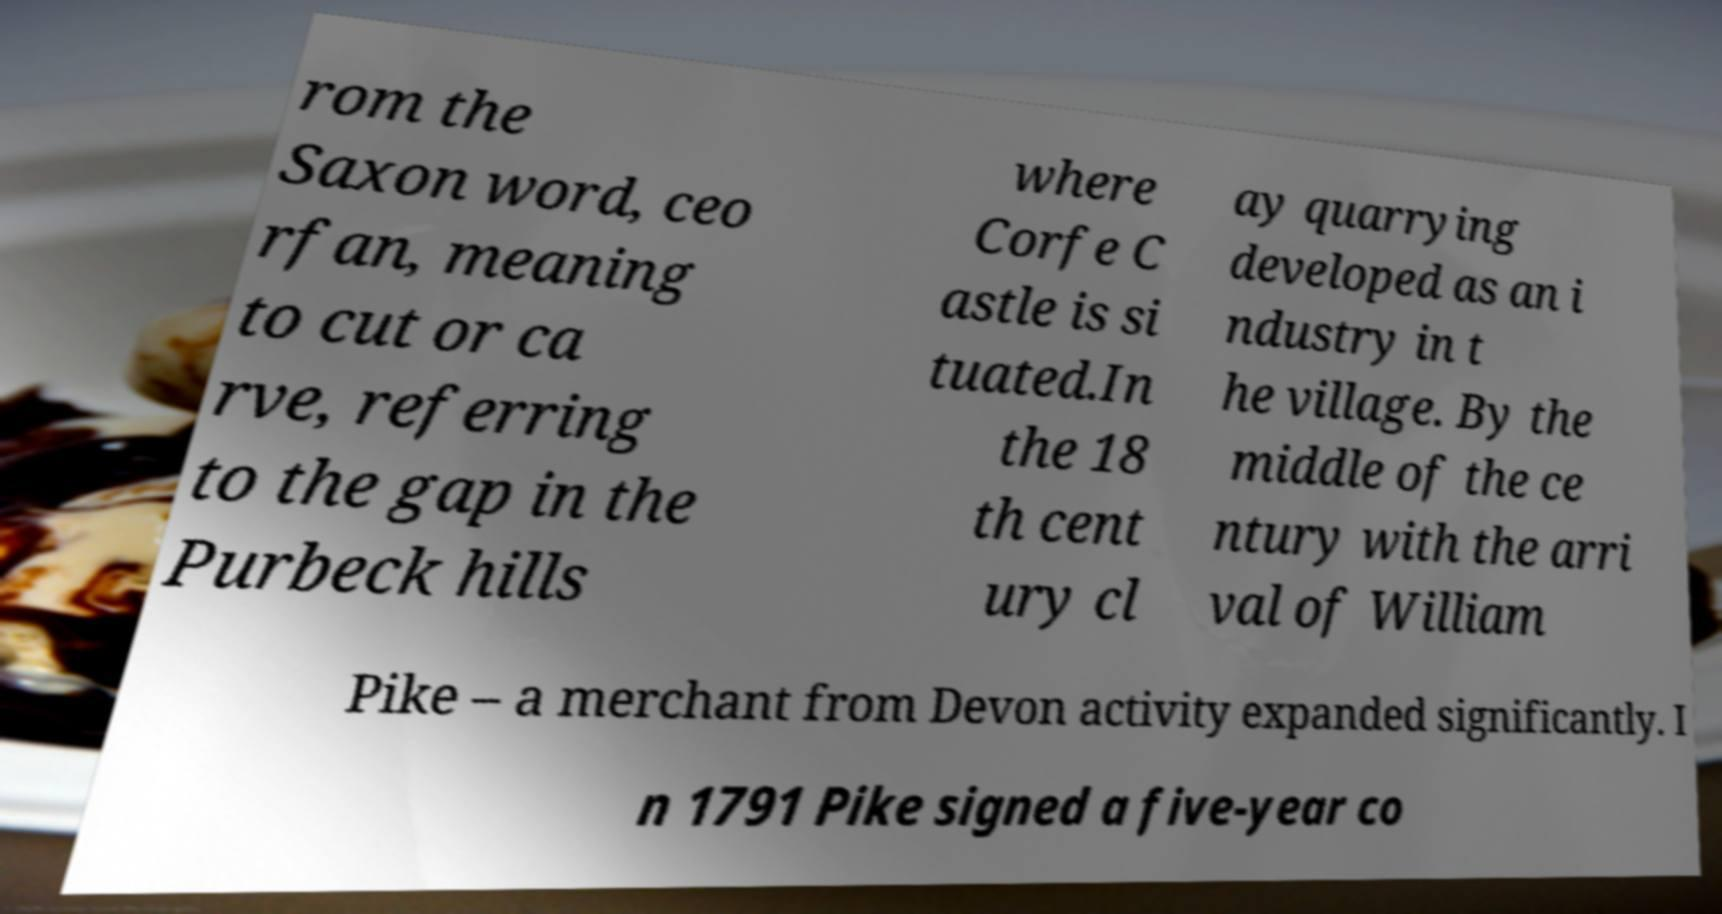What messages or text are displayed in this image? I need them in a readable, typed format. rom the Saxon word, ceo rfan, meaning to cut or ca rve, referring to the gap in the Purbeck hills where Corfe C astle is si tuated.In the 18 th cent ury cl ay quarrying developed as an i ndustry in t he village. By the middle of the ce ntury with the arri val of William Pike – a merchant from Devon activity expanded significantly. I n 1791 Pike signed a five-year co 